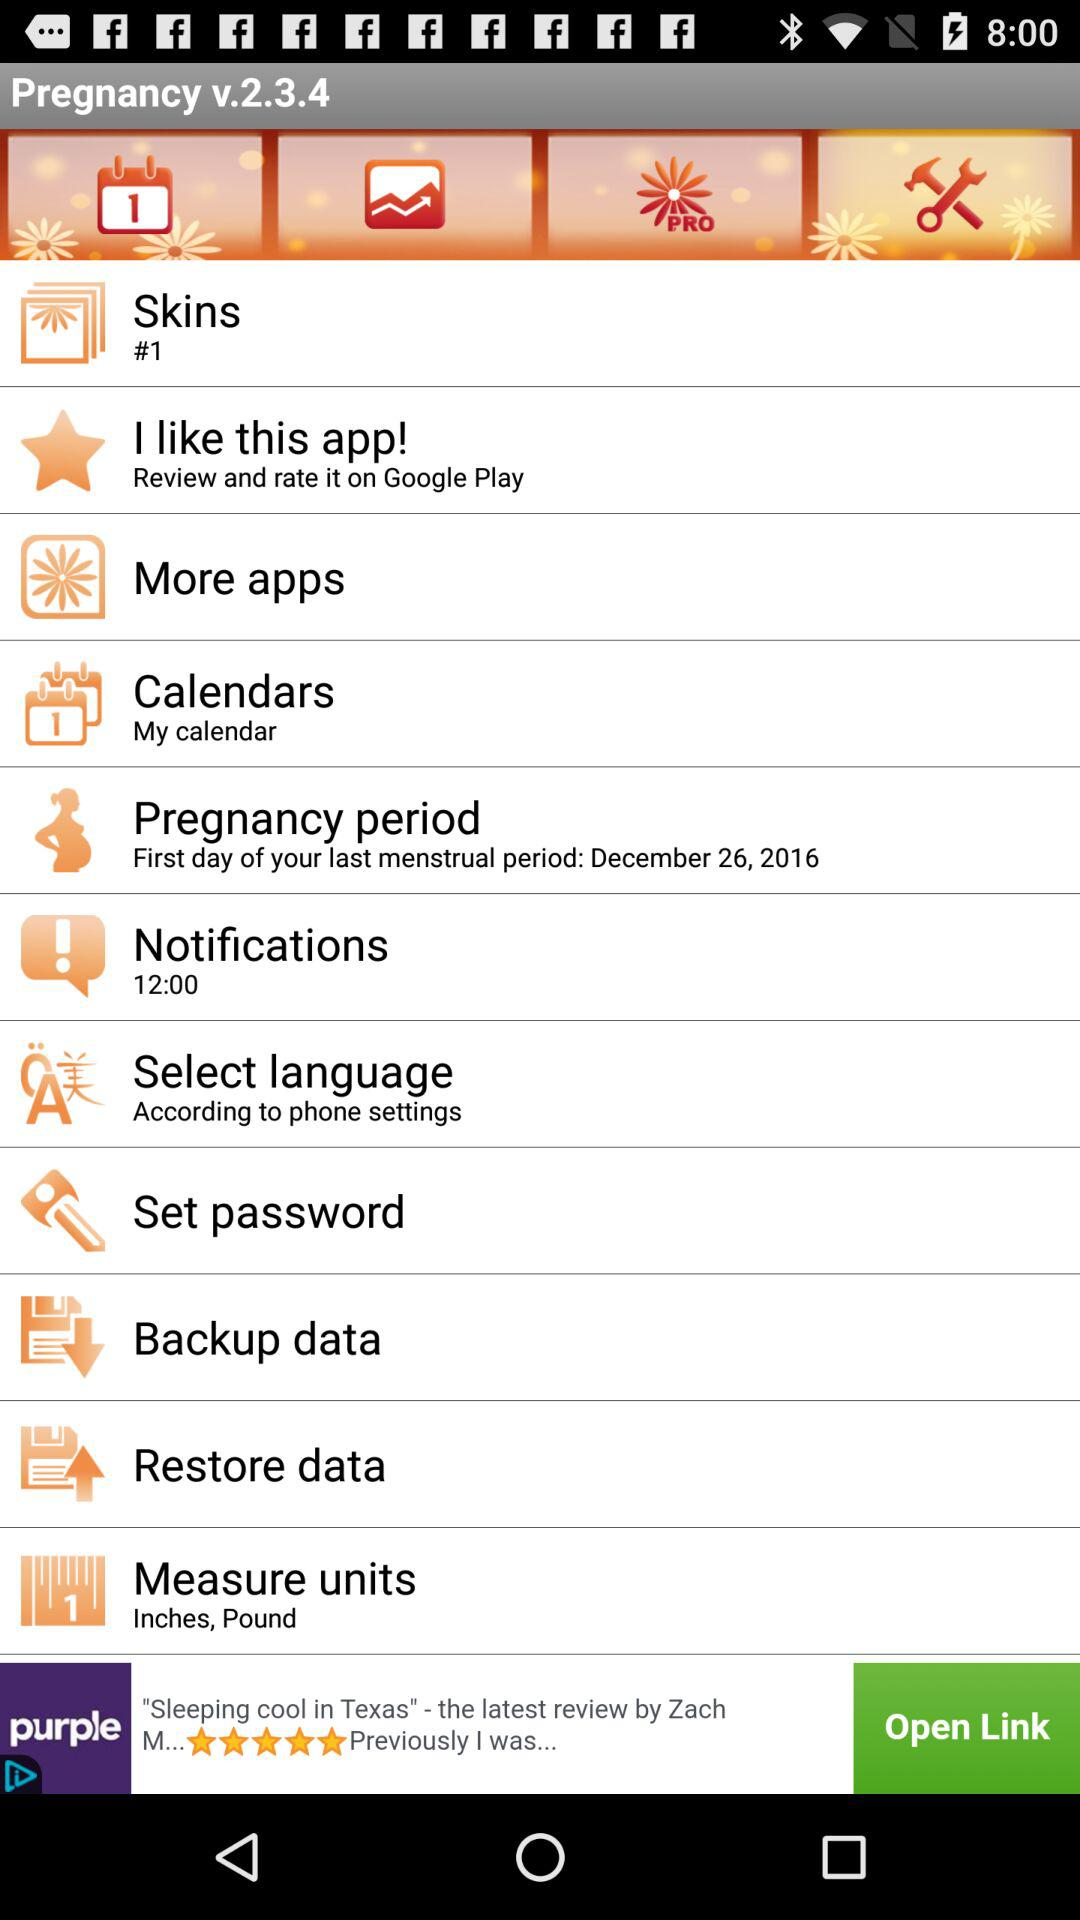What is the version of the app? The version of the app is v.2.3.4. 